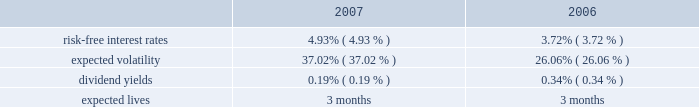Notes to consolidated financial statements 2014 ( continued ) the weighted average grant-date fair value of share awards granted in the years ended may 31 , 2007 and 2006 was $ 45 and $ 36 , respectively .
The total fair value of share awards vested during the years ended may 31 , 2008 , 2007 and 2006 was $ 4.1 million , $ 1.7 million and $ 1.4 million , respectively .
We recognized compensation expenses for restricted stock of $ 5.7 million , $ 2.7 million , and $ 1.6 million in the years ended may 31 , 2008 , 2007 and 2006 .
As of may 31 , 2008 , there was $ 15.2 million of total unrecognized compensation cost related to unvested restricted stock awards that is expected to be recognized over a weighted average period of 2.9 years .
Employee stock purchase plan we have an employee stock purchase plan under which the sale of 2.4 million shares of our common stock has been authorized .
Employees may designate up to the lesser of $ 25 thousand or 20% ( 20 % ) of their annual compensation for the purchase of stock .
For periods prior to october 1 , 2006 , the price for shares purchased under the plan was the lower of 85% ( 85 % ) of the market value on the first day or the last day of the quarterly purchase period .
With the quarterly purchase period beginning on october 1 , 2006 , the price for shares purchased under the plan is 85% ( 85 % ) of the market value on the last day of the quarterly purchase period ( the 201cpurchase date 201d ) .
At may 31 , 2008 , 0.7 million shares had been issued under this plan , with 1.7 million shares reserved for future issuance .
The weighted average grant-date fair value of each designated share purchased under this plan was $ 6 , $ 8 and $ 8 in the years ended may 31 , 2008 , 2007 and 2006 , respectively .
For the quarterly purchases after october 1 , 2006 , the fair value of each designated share purchased under the employee stock purchase plan is based on the 15% ( 15 % ) discount on the purchase date .
For purchases prior to october 1 , 2006 , the fair value of each designated share purchased under the employee stock purchase plan was estimated on the date of grant using the black-scholes valuation model using the following weighted average assumptions: .
The risk-free interest rate is based on the yield of a zero coupon united states treasury security with a maturity equal to the expected life of the option from the date of the grant .
Our assumption on expected volatility is based on our historical volatility .
The dividend yield assumption is calculated using our average stock price over the preceding year and the annualized amount of our current quarterly dividend .
Since the purchase price for shares under the plan is based on the market value on the first day or last day of the quarterly purchase period , we use an expected life of three months to determine the fair value of each designated share. .
What is the percentage change in the weighted average grant-date fair value of share awards from 2006 to 2007? 
Computations: ((45 - 36) / 36)
Answer: 0.25. 